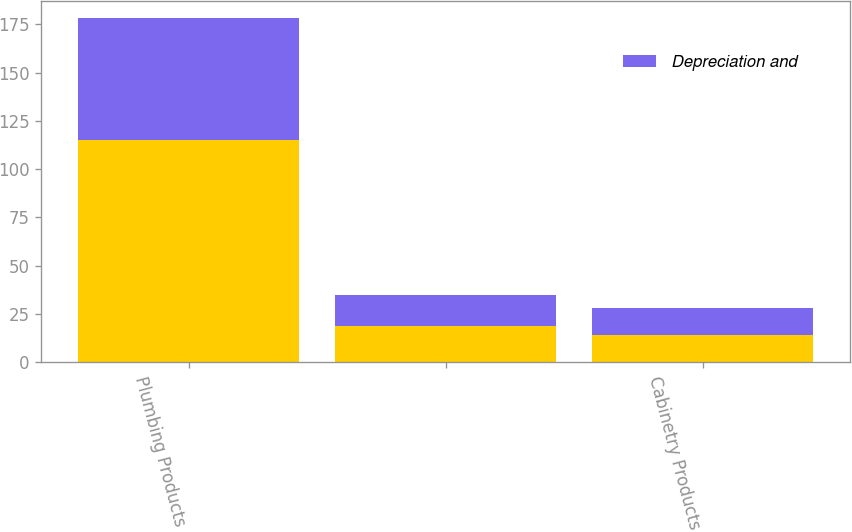Convert chart. <chart><loc_0><loc_0><loc_500><loc_500><stacked_bar_chart><ecel><fcel>Plumbing Products<fcel>Unnamed: 2<fcel>Cabinetry Products<nl><fcel>nan<fcel>115<fcel>19<fcel>14<nl><fcel>Depreciation and<fcel>63<fcel>16<fcel>14<nl></chart> 